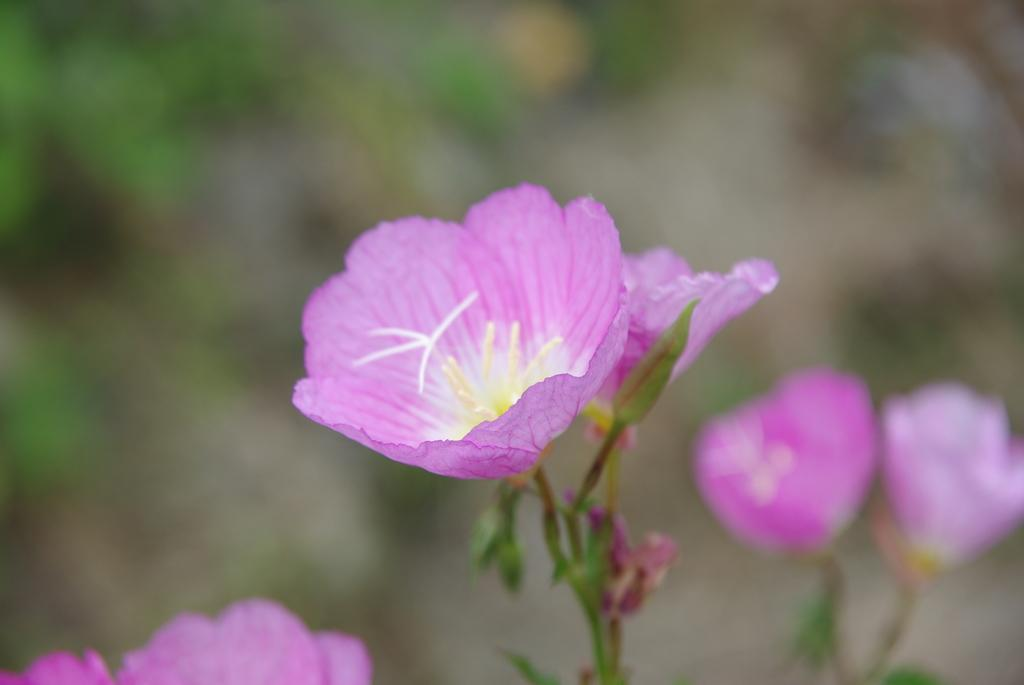What type of flowers can be seen on the plant in the image? There are pink color flowers on a plant in the image. Can you describe the background of the image? The background of the image is blurry. What season is depicted in the image? The season is not depicted in the image, as there is no information about the time of year. 